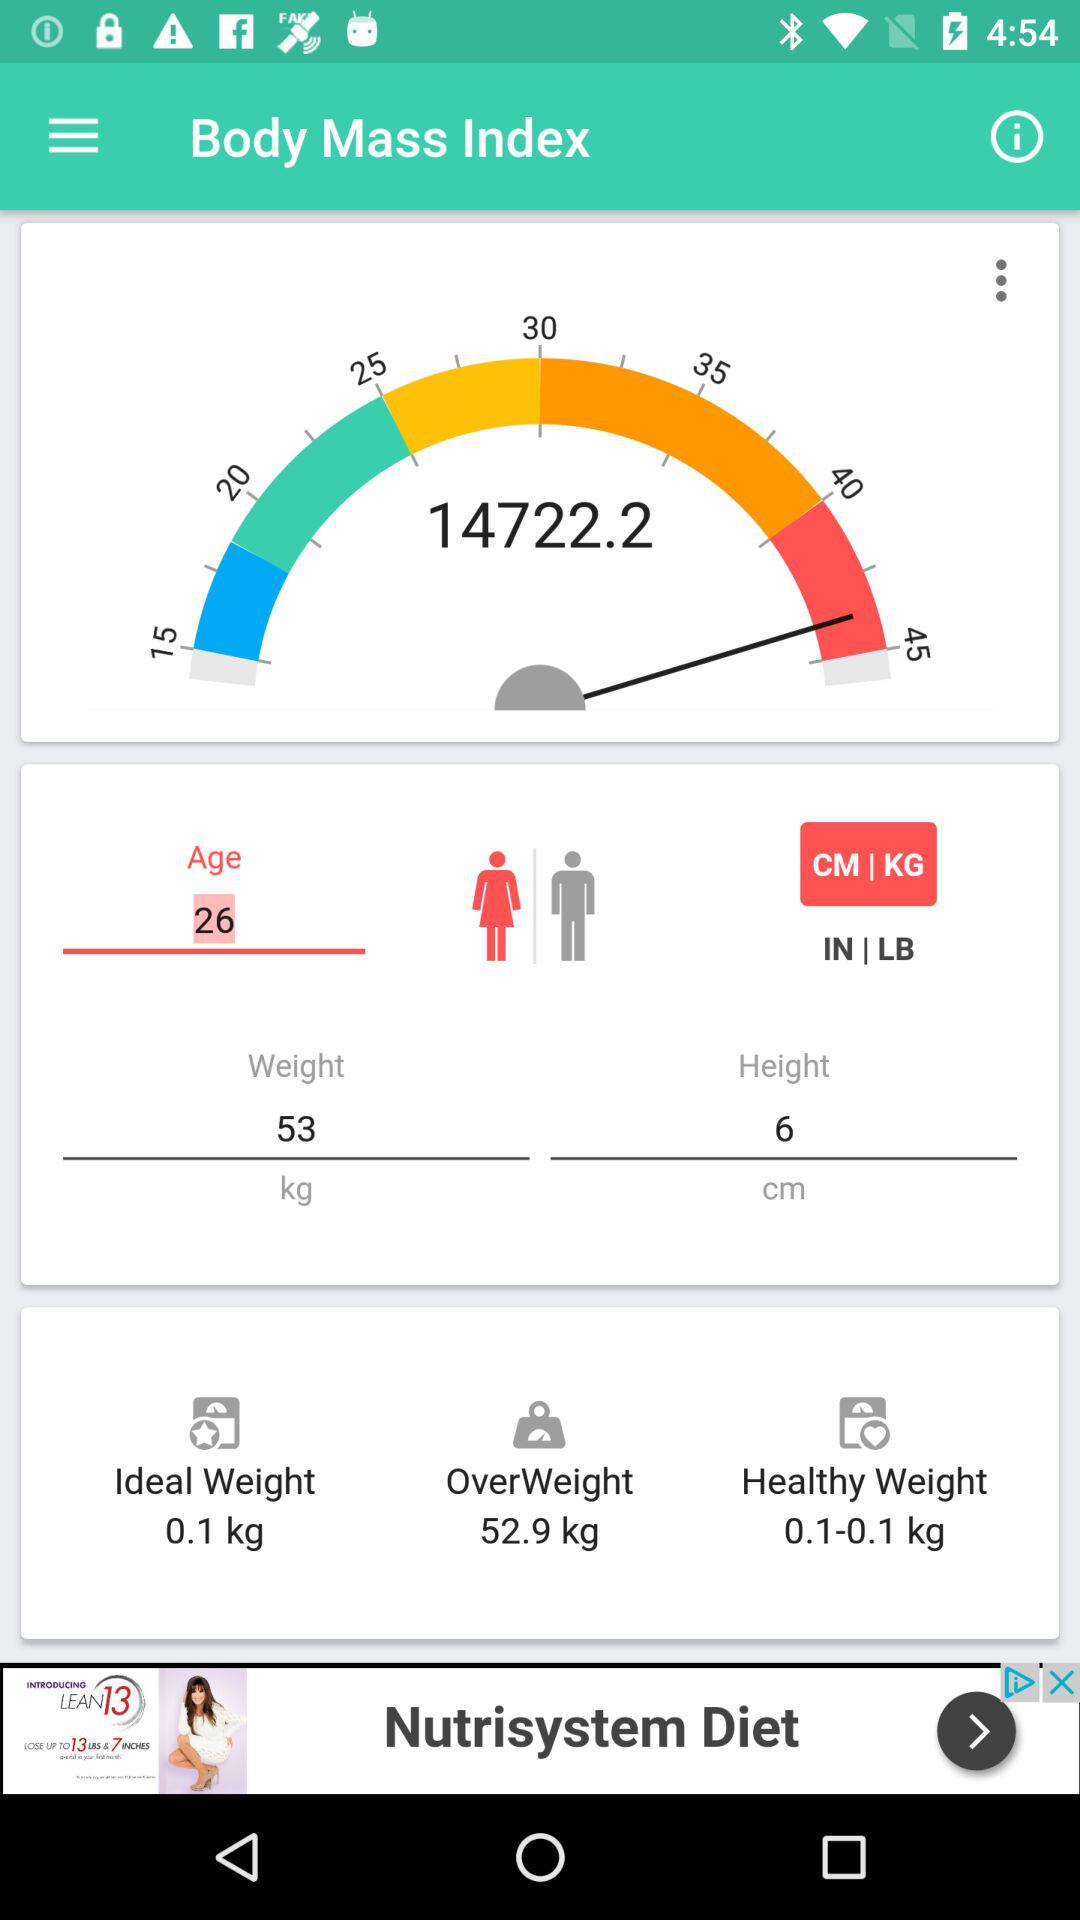What is the app name?
When the provided information is insufficient, respond with <no answer>. <no answer> 